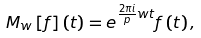Convert formula to latex. <formula><loc_0><loc_0><loc_500><loc_500>M _ { w } \left [ f \right ] \left ( t \right ) = e ^ { \frac { 2 \pi i } { p } w t } f \left ( t \right ) ,</formula> 